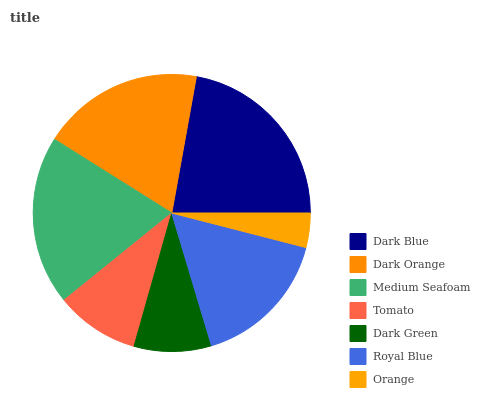Is Orange the minimum?
Answer yes or no. Yes. Is Dark Blue the maximum?
Answer yes or no. Yes. Is Dark Orange the minimum?
Answer yes or no. No. Is Dark Orange the maximum?
Answer yes or no. No. Is Dark Blue greater than Dark Orange?
Answer yes or no. Yes. Is Dark Orange less than Dark Blue?
Answer yes or no. Yes. Is Dark Orange greater than Dark Blue?
Answer yes or no. No. Is Dark Blue less than Dark Orange?
Answer yes or no. No. Is Royal Blue the high median?
Answer yes or no. Yes. Is Royal Blue the low median?
Answer yes or no. Yes. Is Dark Green the high median?
Answer yes or no. No. Is Dark Blue the low median?
Answer yes or no. No. 